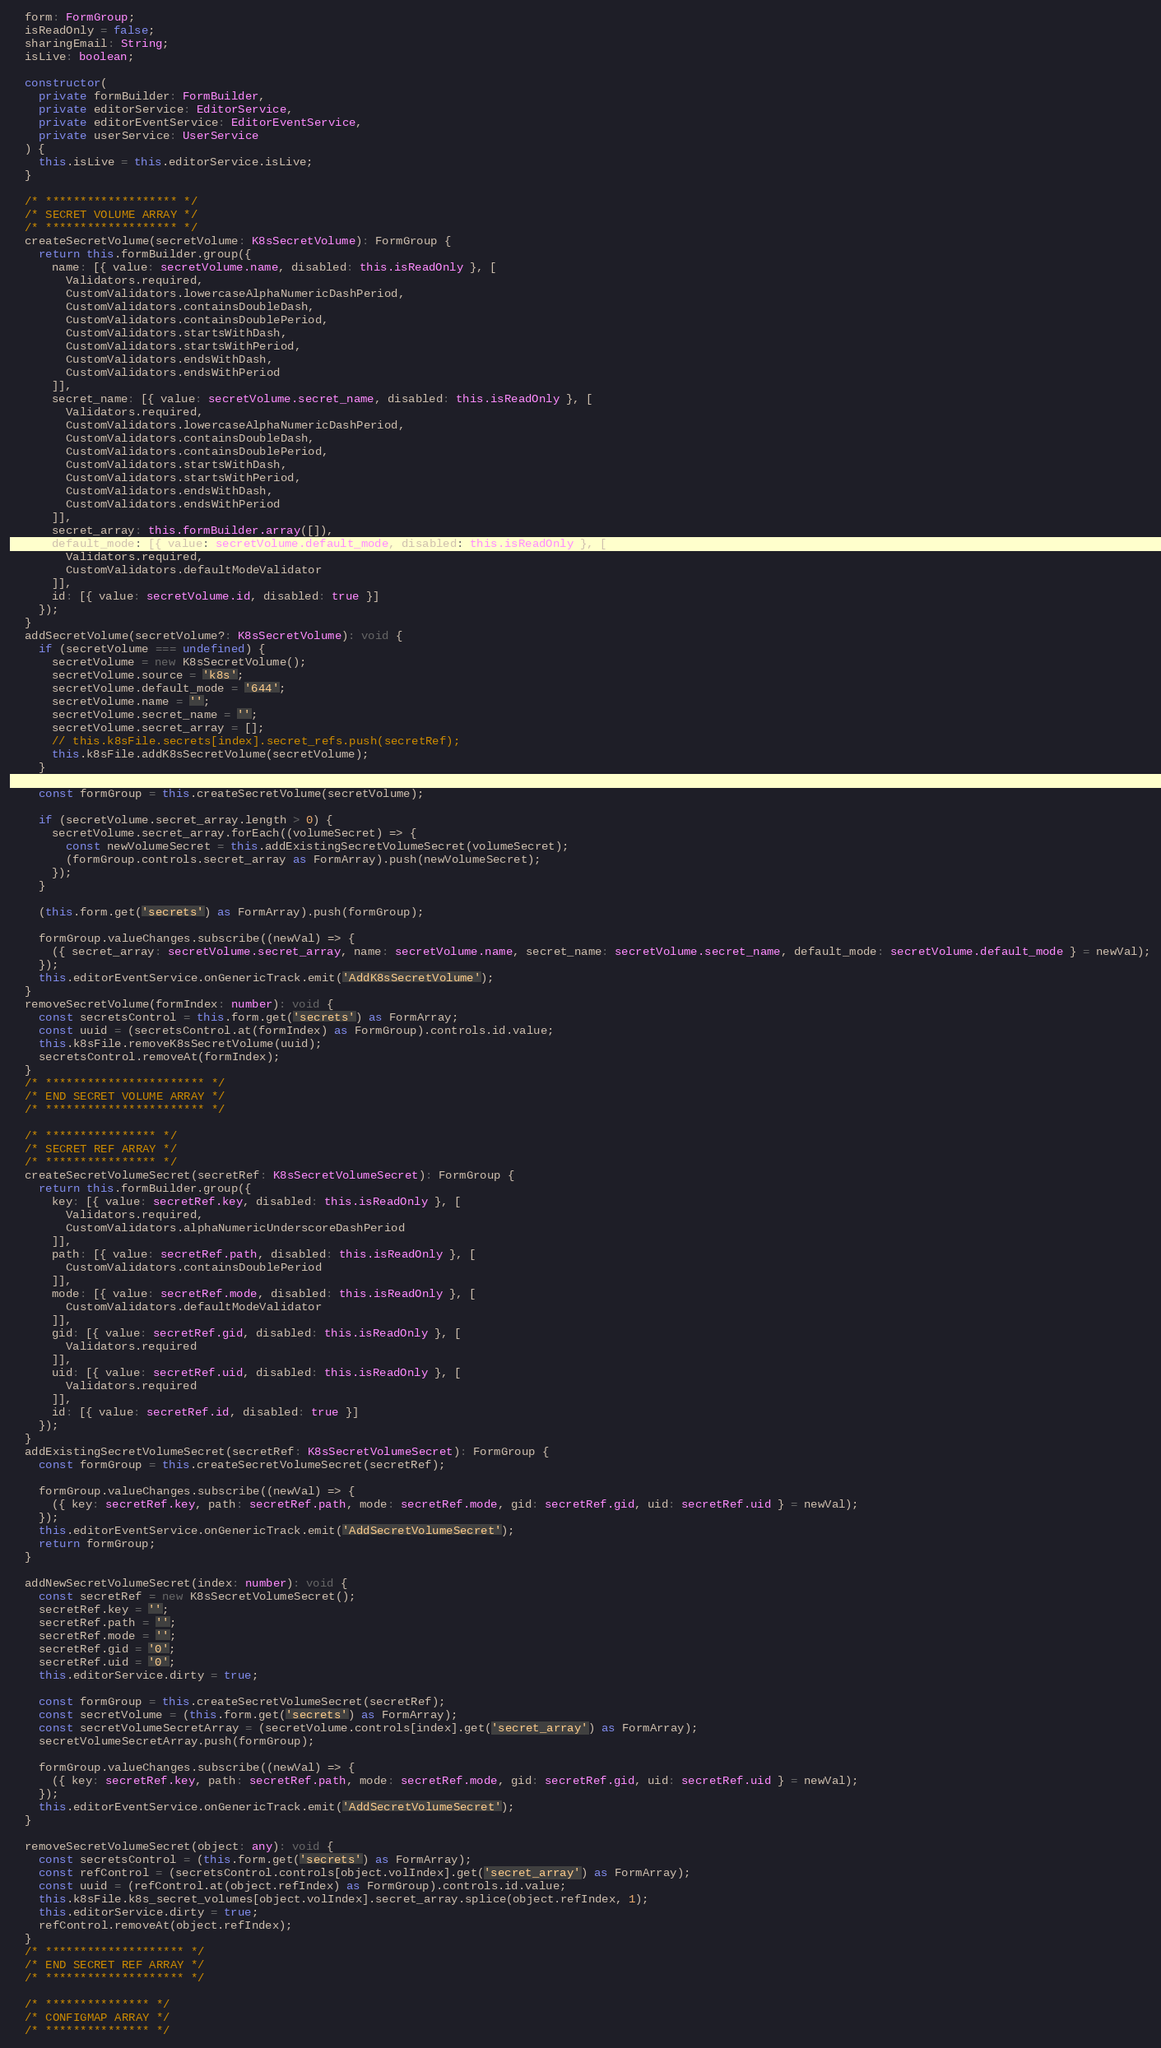Convert code to text. <code><loc_0><loc_0><loc_500><loc_500><_TypeScript_>  form: FormGroup;
  isReadOnly = false;
  sharingEmail: String;
  isLive: boolean;

  constructor(
    private formBuilder: FormBuilder,
    private editorService: EditorService,
    private editorEventService: EditorEventService,
    private userService: UserService
  ) {
    this.isLive = this.editorService.isLive;
  }

  /* ******************* */
  /* SECRET VOLUME ARRAY */
  /* ******************* */
  createSecretVolume(secretVolume: K8sSecretVolume): FormGroup {
    return this.formBuilder.group({
      name: [{ value: secretVolume.name, disabled: this.isReadOnly }, [
        Validators.required,
        CustomValidators.lowercaseAlphaNumericDashPeriod,
        CustomValidators.containsDoubleDash,
        CustomValidators.containsDoublePeriod,
        CustomValidators.startsWithDash,
        CustomValidators.startsWithPeriod,
        CustomValidators.endsWithDash,
        CustomValidators.endsWithPeriod
      ]],
      secret_name: [{ value: secretVolume.secret_name, disabled: this.isReadOnly }, [
        Validators.required,
        CustomValidators.lowercaseAlphaNumericDashPeriod,
        CustomValidators.containsDoubleDash,
        CustomValidators.containsDoublePeriod,
        CustomValidators.startsWithDash,
        CustomValidators.startsWithPeriod,
        CustomValidators.endsWithDash,
        CustomValidators.endsWithPeriod
      ]],
      secret_array: this.formBuilder.array([]),
      default_mode: [{ value: secretVolume.default_mode, disabled: this.isReadOnly }, [
        Validators.required,
        CustomValidators.defaultModeValidator
      ]],
      id: [{ value: secretVolume.id, disabled: true }]
    });
  }
  addSecretVolume(secretVolume?: K8sSecretVolume): void {
    if (secretVolume === undefined) {
      secretVolume = new K8sSecretVolume();
      secretVolume.source = 'k8s';
      secretVolume.default_mode = '644';
      secretVolume.name = '';
      secretVolume.secret_name = '';
      secretVolume.secret_array = [];
      // this.k8sFile.secrets[index].secret_refs.push(secretRef);
      this.k8sFile.addK8sSecretVolume(secretVolume);
    }

    const formGroup = this.createSecretVolume(secretVolume);

    if (secretVolume.secret_array.length > 0) {
      secretVolume.secret_array.forEach((volumeSecret) => {
        const newVolumeSecret = this.addExistingSecretVolumeSecret(volumeSecret);
        (formGroup.controls.secret_array as FormArray).push(newVolumeSecret);
      });
    }

    (this.form.get('secrets') as FormArray).push(formGroup);

    formGroup.valueChanges.subscribe((newVal) => {
      ({ secret_array: secretVolume.secret_array, name: secretVolume.name, secret_name: secretVolume.secret_name, default_mode: secretVolume.default_mode } = newVal);
    });
    this.editorEventService.onGenericTrack.emit('AddK8sSecretVolume');
  }
  removeSecretVolume(formIndex: number): void {
    const secretsControl = this.form.get('secrets') as FormArray;
    const uuid = (secretsControl.at(formIndex) as FormGroup).controls.id.value;
    this.k8sFile.removeK8sSecretVolume(uuid);
    secretsControl.removeAt(formIndex);
  }
  /* *********************** */
  /* END SECRET VOLUME ARRAY */
  /* *********************** */

  /* **************** */
  /* SECRET REF ARRAY */
  /* **************** */
  createSecretVolumeSecret(secretRef: K8sSecretVolumeSecret): FormGroup {
    return this.formBuilder.group({
      key: [{ value: secretRef.key, disabled: this.isReadOnly }, [
        Validators.required,
        CustomValidators.alphaNumericUnderscoreDashPeriod
      ]],
      path: [{ value: secretRef.path, disabled: this.isReadOnly }, [
        CustomValidators.containsDoublePeriod
      ]],
      mode: [{ value: secretRef.mode, disabled: this.isReadOnly }, [
        CustomValidators.defaultModeValidator
      ]],
      gid: [{ value: secretRef.gid, disabled: this.isReadOnly }, [
        Validators.required
      ]],
      uid: [{ value: secretRef.uid, disabled: this.isReadOnly }, [
        Validators.required
      ]],
      id: [{ value: secretRef.id, disabled: true }]
    });
  }
  addExistingSecretVolumeSecret(secretRef: K8sSecretVolumeSecret): FormGroup {
    const formGroup = this.createSecretVolumeSecret(secretRef);

    formGroup.valueChanges.subscribe((newVal) => {
      ({ key: secretRef.key, path: secretRef.path, mode: secretRef.mode, gid: secretRef.gid, uid: secretRef.uid } = newVal);
    });
    this.editorEventService.onGenericTrack.emit('AddSecretVolumeSecret');
    return formGroup;
  }

  addNewSecretVolumeSecret(index: number): void {
    const secretRef = new K8sSecretVolumeSecret();
    secretRef.key = '';
    secretRef.path = '';
    secretRef.mode = '';
    secretRef.gid = '0';
    secretRef.uid = '0';
    this.editorService.dirty = true;

    const formGroup = this.createSecretVolumeSecret(secretRef);
    const secretVolume = (this.form.get('secrets') as FormArray);
    const secretVolumeSecretArray = (secretVolume.controls[index].get('secret_array') as FormArray);
    secretVolumeSecretArray.push(formGroup);

    formGroup.valueChanges.subscribe((newVal) => {
      ({ key: secretRef.key, path: secretRef.path, mode: secretRef.mode, gid: secretRef.gid, uid: secretRef.uid } = newVal);
    });
    this.editorEventService.onGenericTrack.emit('AddSecretVolumeSecret');
  }

  removeSecretVolumeSecret(object: any): void {
    const secretsControl = (this.form.get('secrets') as FormArray);
    const refControl = (secretsControl.controls[object.volIndex].get('secret_array') as FormArray);
    const uuid = (refControl.at(object.refIndex) as FormGroup).controls.id.value;
    this.k8sFile.k8s_secret_volumes[object.volIndex].secret_array.splice(object.refIndex, 1);
    this.editorService.dirty = true;
    refControl.removeAt(object.refIndex);
  }
  /* ******************** */
  /* END SECRET REF ARRAY */
  /* ******************** */

  /* *************** */
  /* CONFIGMAP ARRAY */
  /* *************** */</code> 